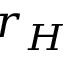<formula> <loc_0><loc_0><loc_500><loc_500>r _ { H }</formula> 